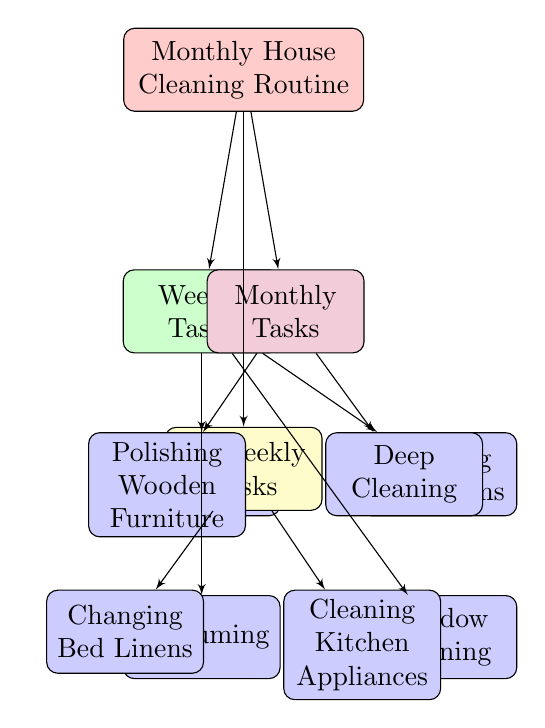What's the main focus of the diagram? The main focus of the diagram is the "Monthly House Cleaning Routine." This is the topmost node that provides the overall theme of the flowchart.
Answer: Monthly House Cleaning Routine How many types of cleaning tasks are presented in the diagram? The diagram shows three types of cleaning tasks: "Weekly Tasks," "Bi-Weekly Tasks," and "Monthly Tasks." Each of these categories has its own corresponding cleaning activities.
Answer: Three types What task is listed under Bi-Weekly Tasks? "Changing Bed Linens" is mentioned as one of the tasks under the Bi-Weekly Tasks section of the diagram.
Answer: Changing Bed Linens Which specific task relates to dusting furniture? The specific task that relates to dusting furniture is "Dusting Furniture." This task is categorized under the Weekly Tasks.
Answer: Dusting Furniture Which task requires cleaning kitchen appliances? "Cleaning Kitchen Appliances" is the task associated with that activity, located in the Bi-Weekly Tasks section of the diagram.
Answer: Cleaning Kitchen Appliances Are there any tasks associated with deep cleaning? Yes, "Deep Cleaning" is one of the tasks categorized under Monthly Tasks in the diagram.
Answer: Deep Cleaning How many tasks are listed under Weekly Tasks? There are four tasks listed under Weekly Tasks: "Dusting Furniture," "Cleaning Bathrooms," "Vacuuming," and "Window Cleaning." Therefore, the total is four tasks.
Answer: Four tasks Which cleaning task is specifically for polishing wooden items? The task specifically for polishing wooden items is "Polishing Wooden Furniture," which is categorized under Monthly Tasks in the diagram.
Answer: Polishing Wooden Furniture How do Bi-Weekly Tasks relate to Monthly Tasks in the diagram? Bi-Weekly Tasks and Monthly Tasks are both types of tasks that fall under the main node, "Monthly House Cleaning Routine," indicating that they are part of the overall cleaning schedule.
Answer: They are both types of tasks under the main routine 